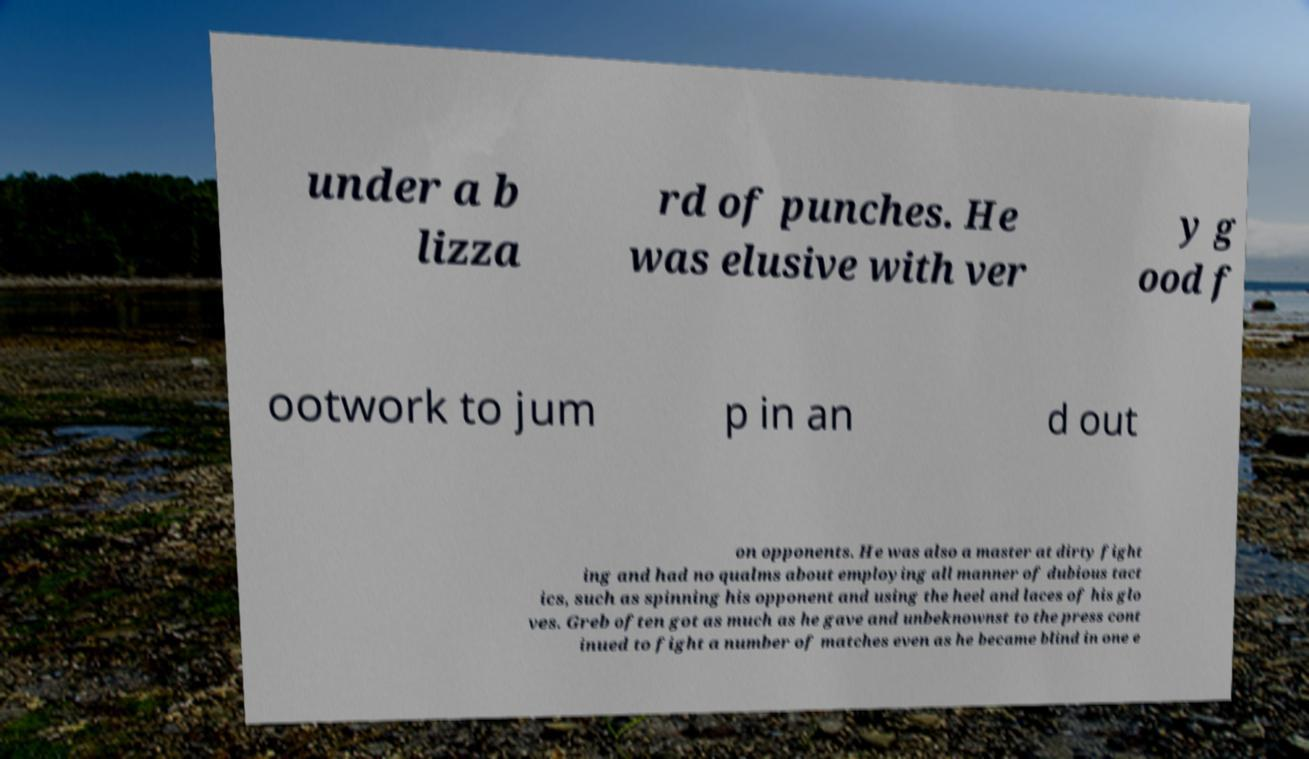Please read and relay the text visible in this image. What does it say? under a b lizza rd of punches. He was elusive with ver y g ood f ootwork to jum p in an d out on opponents. He was also a master at dirty fight ing and had no qualms about employing all manner of dubious tact ics, such as spinning his opponent and using the heel and laces of his glo ves. Greb often got as much as he gave and unbeknownst to the press cont inued to fight a number of matches even as he became blind in one e 